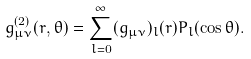<formula> <loc_0><loc_0><loc_500><loc_500>g ^ { ( 2 ) } _ { \mu \nu } ( r , \theta ) = \sum _ { l = 0 } ^ { \infty } ( g _ { \mu \nu } ) _ { l } ( r ) P _ { l } ( \cos \theta ) .</formula> 